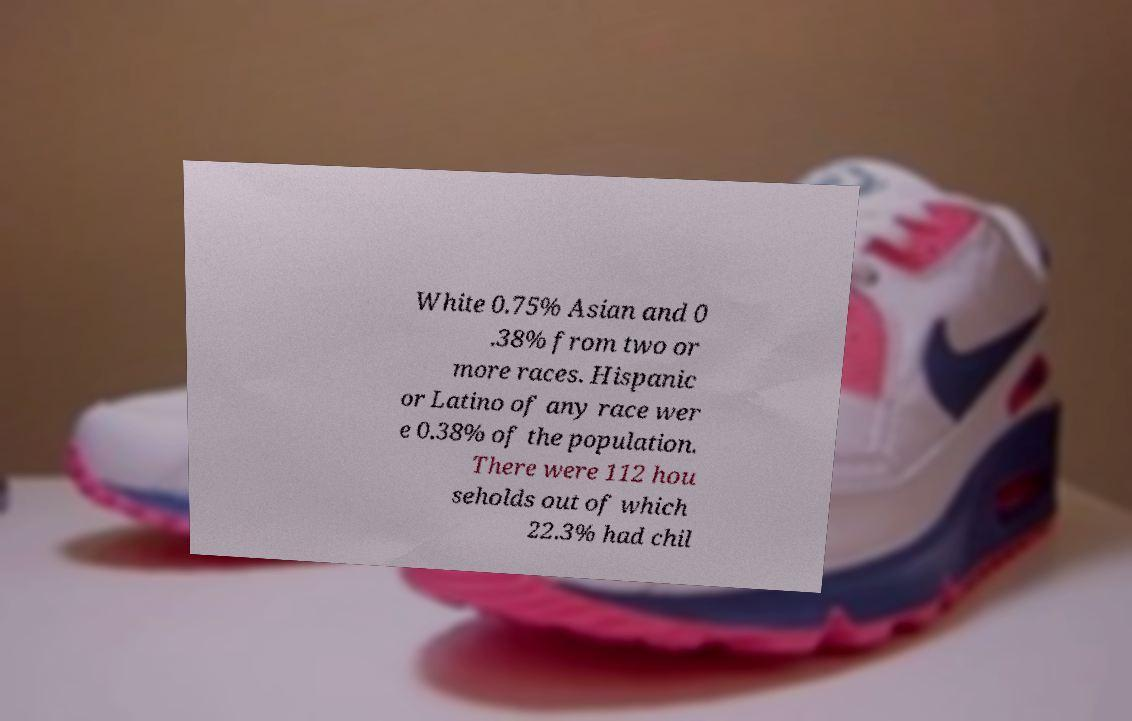What messages or text are displayed in this image? I need them in a readable, typed format. White 0.75% Asian and 0 .38% from two or more races. Hispanic or Latino of any race wer e 0.38% of the population. There were 112 hou seholds out of which 22.3% had chil 